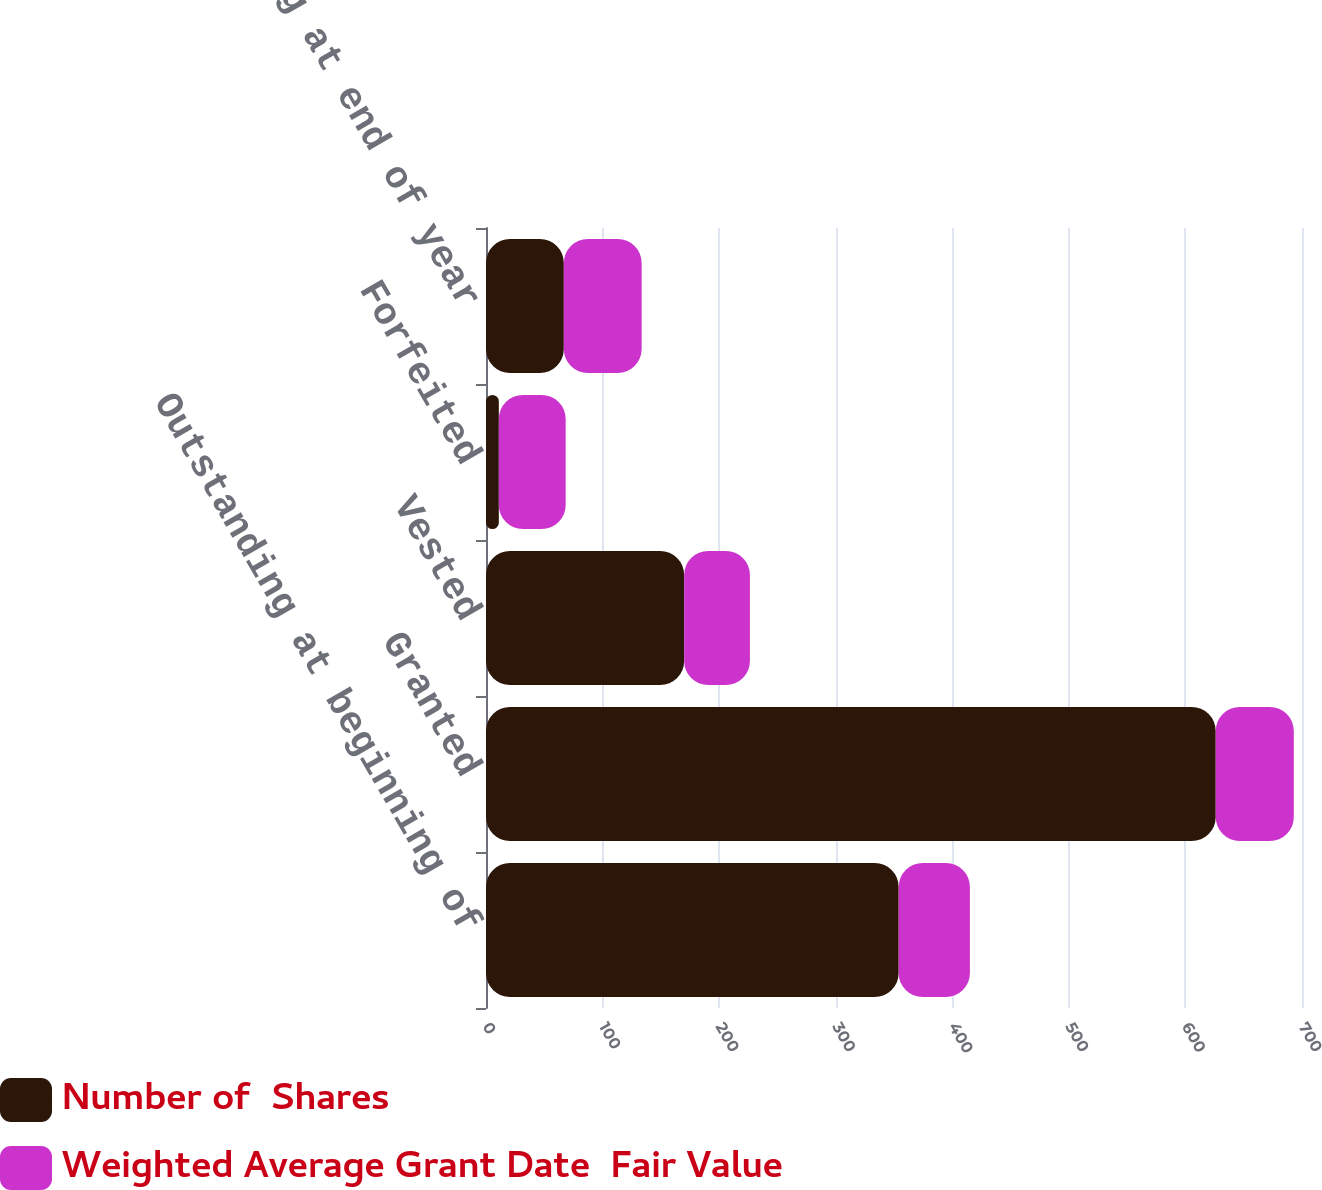Convert chart to OTSL. <chart><loc_0><loc_0><loc_500><loc_500><stacked_bar_chart><ecel><fcel>Outstanding at beginning of<fcel>Granted<fcel>Vested<fcel>Forfeited<fcel>Outstanding at end of year<nl><fcel>Number of  Shares<fcel>354<fcel>626<fcel>170<fcel>11<fcel>66.76<nl><fcel>Weighted Average Grant Date  Fair Value<fcel>61.12<fcel>66.97<fcel>56.4<fcel>57.35<fcel>66.76<nl></chart> 